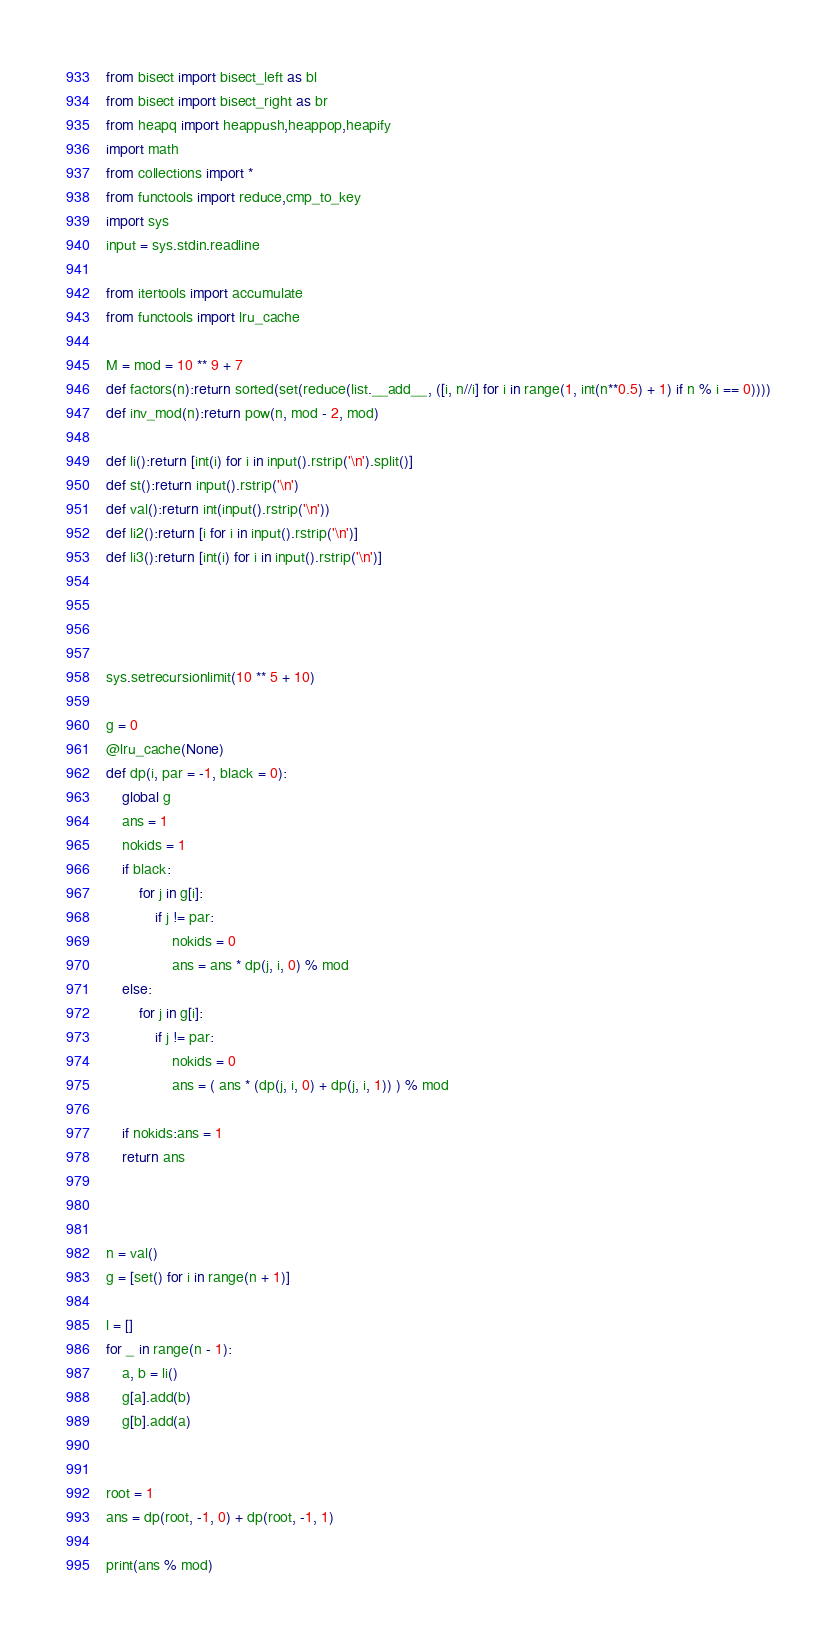<code> <loc_0><loc_0><loc_500><loc_500><_Python_>from bisect import bisect_left as bl
from bisect import bisect_right as br
from heapq import heappush,heappop,heapify
import math
from collections import *
from functools import reduce,cmp_to_key
import sys
input = sys.stdin.readline

from itertools import accumulate
from functools import lru_cache

M = mod = 10 ** 9 + 7
def factors(n):return sorted(set(reduce(list.__add__, ([i, n//i] for i in range(1, int(n**0.5) + 1) if n % i == 0))))
def inv_mod(n):return pow(n, mod - 2, mod)
 
def li():return [int(i) for i in input().rstrip('\n').split()]
def st():return input().rstrip('\n')
def val():return int(input().rstrip('\n'))
def li2():return [i for i in input().rstrip('\n')]
def li3():return [int(i) for i in input().rstrip('\n')]
 



sys.setrecursionlimit(10 ** 5 + 10)

g = 0
@lru_cache(None)
def dp(i, par = -1, black = 0):
    global g
    ans = 1
    nokids = 1
    if black:
        for j in g[i]:
            if j != par:
                nokids = 0
                ans = ans * dp(j, i, 0) % mod
    else:
        for j in g[i]:
            if j != par:
                nokids = 0
                ans = ( ans * (dp(j, i, 0) + dp(j, i, 1)) ) % mod

    if nokids:ans = 1
    return ans



n = val()
g = [set() for i in range(n + 1)]

l = []
for _ in range(n - 1):
    a, b = li()
    g[a].add(b)
    g[b].add(a)


root = 1    
ans = dp(root, -1, 0) + dp(root, -1, 1)

print(ans % mod)</code> 